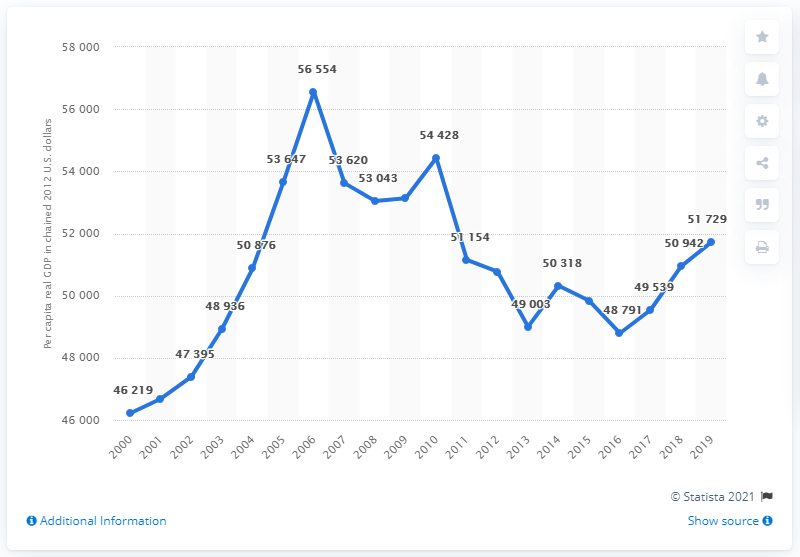Identify some key points in this picture. There have been 11 years in which the per capita real GDP exceeded 50,000 US dollars. The peak of the data occurred in 2006. 